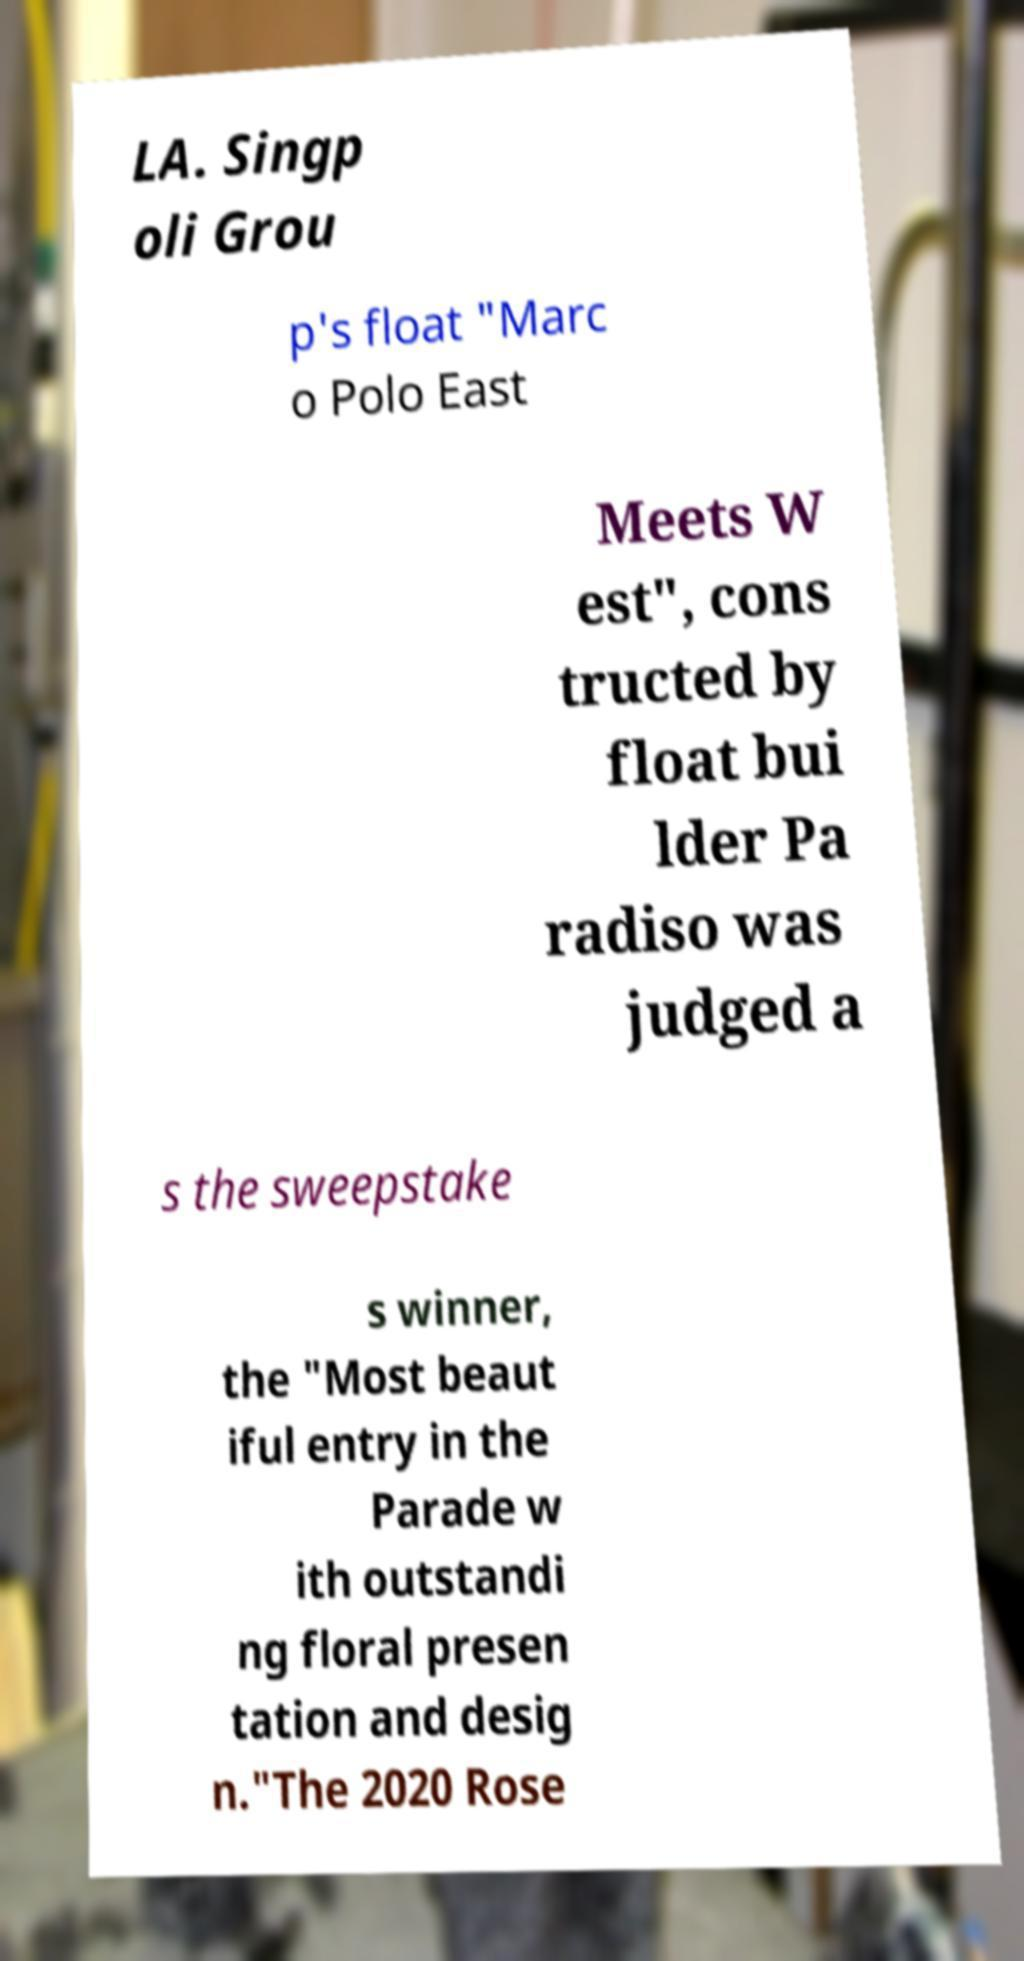Could you extract and type out the text from this image? LA. Singp oli Grou p's float "Marc o Polo East Meets W est", cons tructed by float bui lder Pa radiso was judged a s the sweepstake s winner, the "Most beaut iful entry in the Parade w ith outstandi ng floral presen tation and desig n."The 2020 Rose 